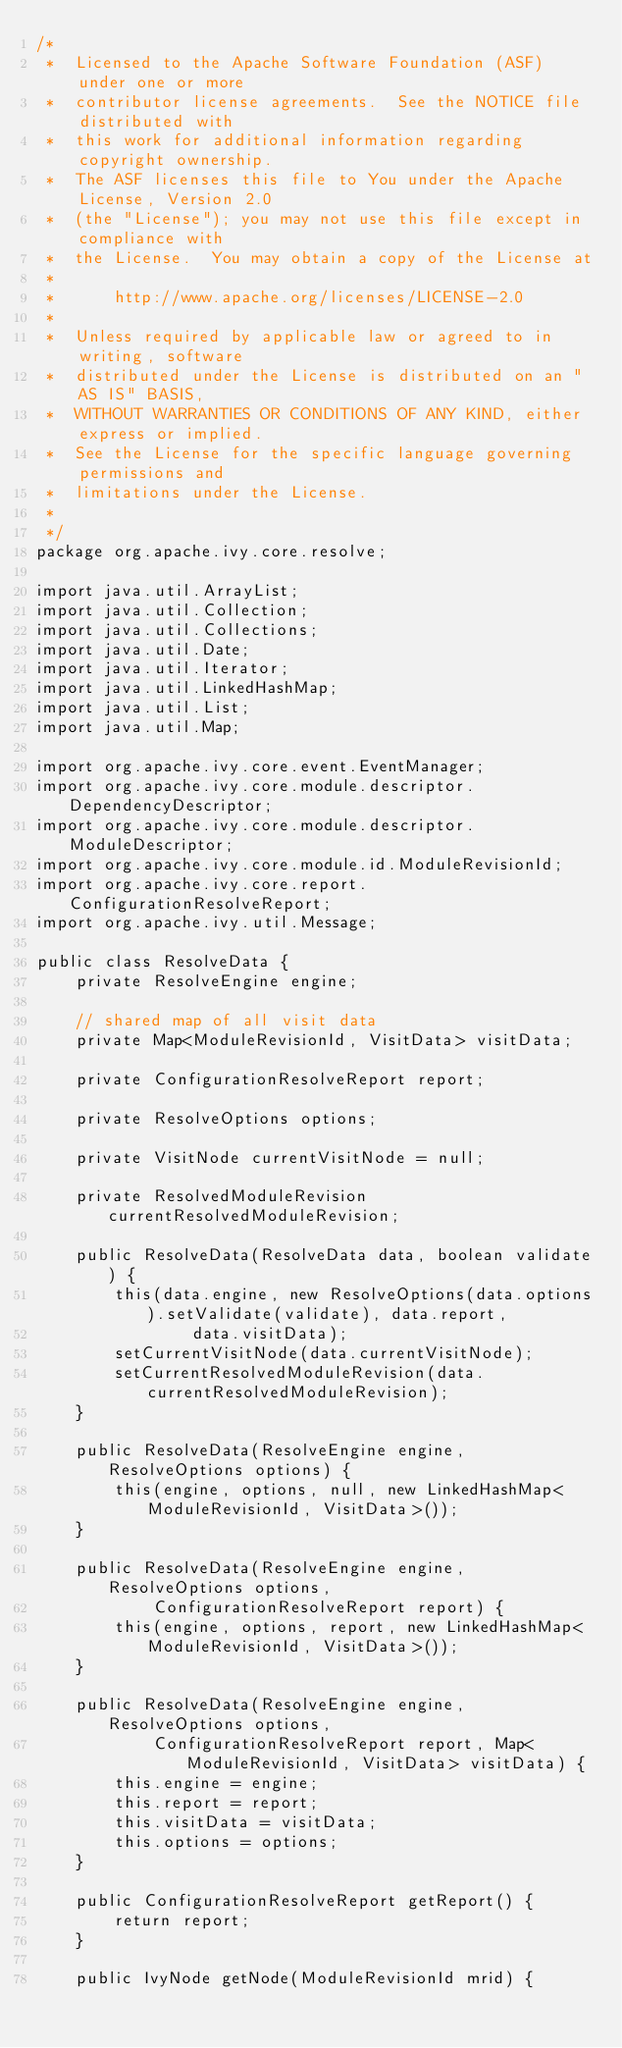Convert code to text. <code><loc_0><loc_0><loc_500><loc_500><_Java_>/*
 *  Licensed to the Apache Software Foundation (ASF) under one or more
 *  contributor license agreements.  See the NOTICE file distributed with
 *  this work for additional information regarding copyright ownership.
 *  The ASF licenses this file to You under the Apache License, Version 2.0
 *  (the "License"); you may not use this file except in compliance with
 *  the License.  You may obtain a copy of the License at
 *
 *      http://www.apache.org/licenses/LICENSE-2.0
 *
 *  Unless required by applicable law or agreed to in writing, software
 *  distributed under the License is distributed on an "AS IS" BASIS,
 *  WITHOUT WARRANTIES OR CONDITIONS OF ANY KIND, either express or implied.
 *  See the License for the specific language governing permissions and
 *  limitations under the License.
 *
 */
package org.apache.ivy.core.resolve;

import java.util.ArrayList;
import java.util.Collection;
import java.util.Collections;
import java.util.Date;
import java.util.Iterator;
import java.util.LinkedHashMap;
import java.util.List;
import java.util.Map;

import org.apache.ivy.core.event.EventManager;
import org.apache.ivy.core.module.descriptor.DependencyDescriptor;
import org.apache.ivy.core.module.descriptor.ModuleDescriptor;
import org.apache.ivy.core.module.id.ModuleRevisionId;
import org.apache.ivy.core.report.ConfigurationResolveReport;
import org.apache.ivy.util.Message;

public class ResolveData {
    private ResolveEngine engine;

    // shared map of all visit data
    private Map<ModuleRevisionId, VisitData> visitData;

    private ConfigurationResolveReport report;

    private ResolveOptions options;

    private VisitNode currentVisitNode = null;

    private ResolvedModuleRevision currentResolvedModuleRevision;

    public ResolveData(ResolveData data, boolean validate) {
        this(data.engine, new ResolveOptions(data.options).setValidate(validate), data.report,
                data.visitData);
        setCurrentVisitNode(data.currentVisitNode);
        setCurrentResolvedModuleRevision(data.currentResolvedModuleRevision);
    }

    public ResolveData(ResolveEngine engine, ResolveOptions options) {
        this(engine, options, null, new LinkedHashMap<ModuleRevisionId, VisitData>());
    }

    public ResolveData(ResolveEngine engine, ResolveOptions options,
            ConfigurationResolveReport report) {
        this(engine, options, report, new LinkedHashMap<ModuleRevisionId, VisitData>());
    }

    public ResolveData(ResolveEngine engine, ResolveOptions options,
            ConfigurationResolveReport report, Map<ModuleRevisionId, VisitData> visitData) {
        this.engine = engine;
        this.report = report;
        this.visitData = visitData;
        this.options = options;
    }

    public ConfigurationResolveReport getReport() {
        return report;
    }

    public IvyNode getNode(ModuleRevisionId mrid) {</code> 